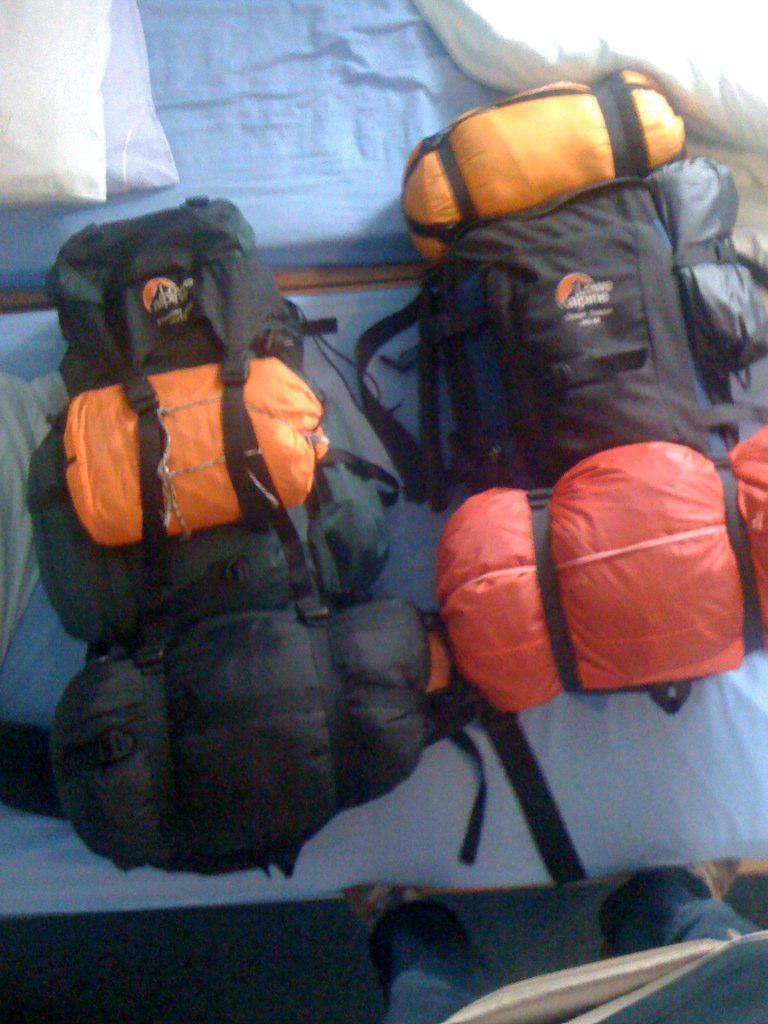Please provide a concise description of this image. This picture is mainly highlighted with two backpacks on a bed. 